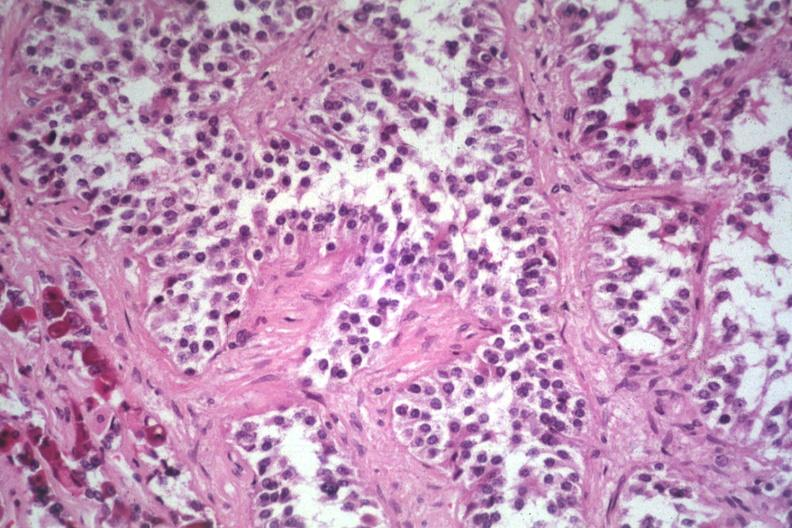what is present?
Answer the question using a single word or phrase. Adenoma 